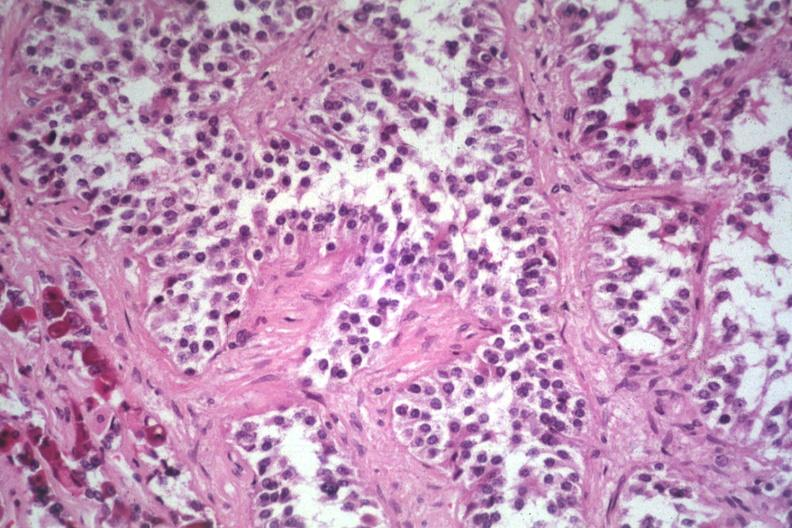what is present?
Answer the question using a single word or phrase. Adenoma 